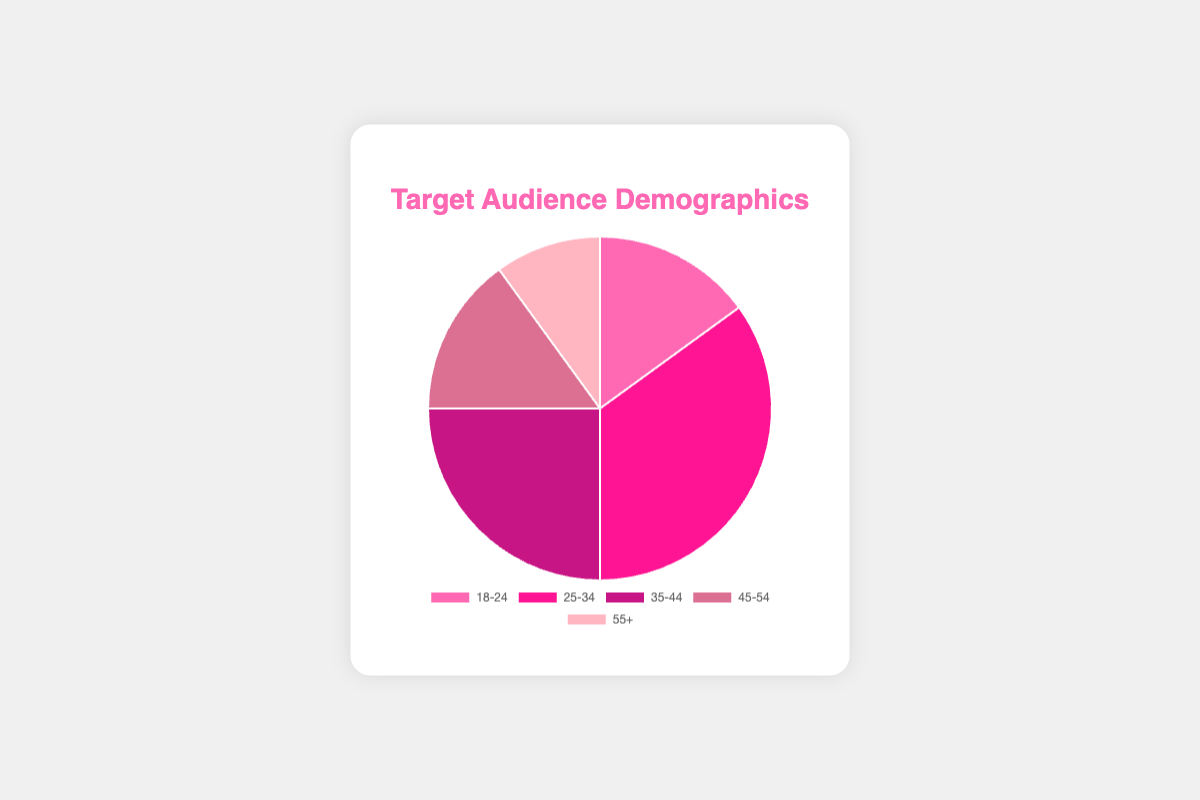What percentage of the target audience is within the age group 25-34? By looking at the data in the figure, the section representing the 25-34 age group has a 35% label.
Answer: 35% What is the combined percentage of the target audience for the 18-24 and 45-54 age groups? Sum the percentages of the 18-24 and 45-54 age groups: 15% + 15% = 30%.
Answer: 30% Which age group has the smallest percentage of the target audience? By examining the figure, the 55+ age group has the smallest percentage at 10%.
Answer: 55+ How does the percentage of the 35-44 age group compare to the percentage of the 18-24 age group? The 35-44 age group has a percentage of 25%, whereas the 18-24 age group has 15%. 25% is greater than 15%.
Answer: 35-44 is greater What is the average percentage of the target audience for the age groups 18-24, 25-34, and 35-44? Calculate the average of the three percentages: (15% + 35% + 25%) / 3 = 25%.
Answer: 25% What is the difference in percentage between the age group with the highest target audience and the age group with the lowest target audience? The highest percentage is 35% (25-34 age group), and the lowest is 10% (55+ age group). The difference is 35% - 10% = 25%.
Answer: 25% Which age group is represented by the most vibrant pink color in the chart? The most vibrant pink color is allocated to the 25-34 age group as visually compared to other sections.
Answer: 25-34 What is the total percentage of the target audience for the age groups above 35? Sum the percentages of the 35-44, 45-54, and 55+ age groups: 25% + 15% + 10% = 50%.
Answer: 50% Is the percentage of the target audience for the 45-54 age group equal to the percentage of the 18-24 age group? Both the 18-24 age group and the 45-54 age group have a percentage of 15%.
Answer: Yes 